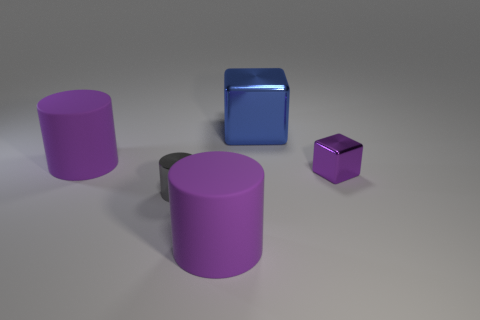What materials do the objects in the image seem to be made of? The aubergine-colored cylinders and the dark blue cube appear to have a matte finish indicative of a plastic material, while the small purple cube has a reflective surface suggestive of a metallic material. 